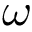<formula> <loc_0><loc_0><loc_500><loc_500>\omega</formula> 